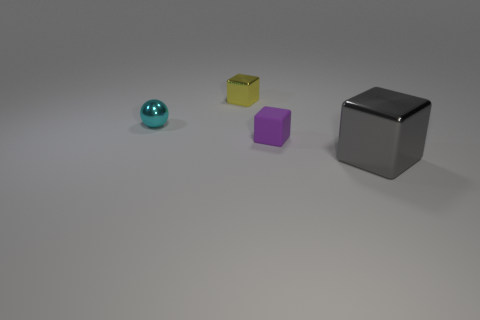How many things are large gray shiny things or blocks behind the big metal cube?
Your response must be concise. 3. There is a block that is both in front of the cyan object and to the left of the gray metal block; what color is it?
Offer a terse response. Purple. Does the yellow block have the same size as the cyan ball?
Keep it short and to the point. Yes. The small block to the right of the small yellow metal object is what color?
Your answer should be compact. Purple. Are there any other big things of the same color as the big shiny object?
Provide a short and direct response. No. There is another metal object that is the same size as the yellow metallic thing; what is its color?
Make the answer very short. Cyan. Do the tiny cyan thing and the yellow metal thing have the same shape?
Your response must be concise. No. There is a tiny object that is in front of the metallic ball; what material is it?
Your answer should be compact. Rubber. The large cube has what color?
Provide a succinct answer. Gray. Do the cube that is behind the small rubber cube and the shiny cube in front of the cyan object have the same size?
Your answer should be compact. No. 